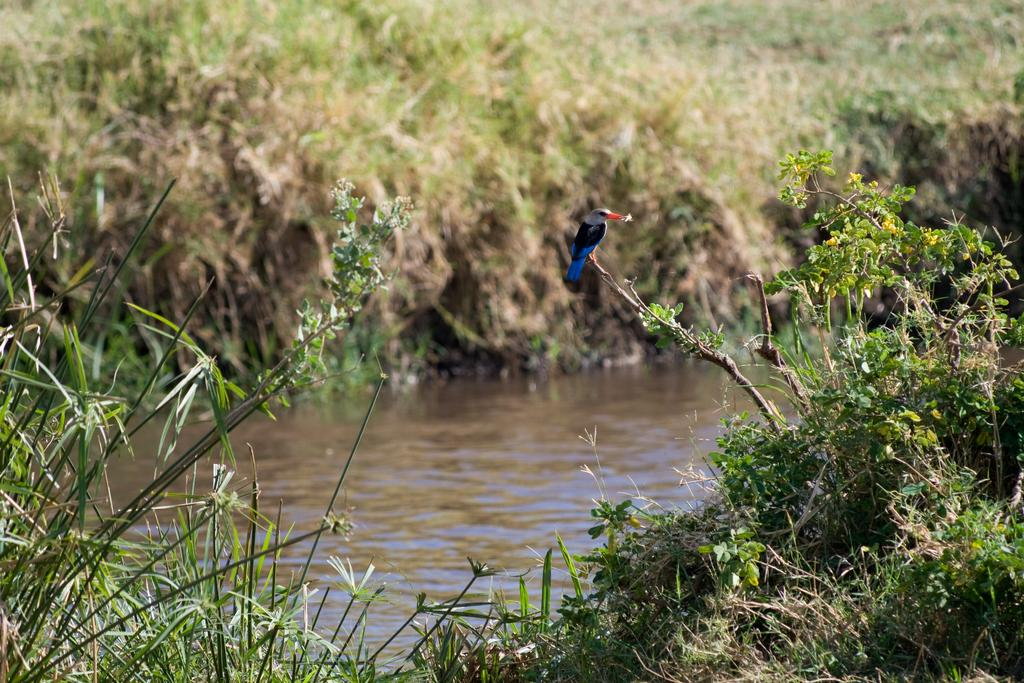What is the main feature in the middle of the image? There is a canal in the middle of the image. What type of vegetation is present near the canal? There is grass beside the canal. Can you describe the bird in the image? A bird is visible on the stem of a plant. How many brothers does the bird have in the image? There is no information about the bird's family in the image, so we cannot determine if it has any brothers. Are there any tomatoes growing near the canal? There is no mention of tomatoes in the provided facts, so we cannot determine if they are present in the image. 